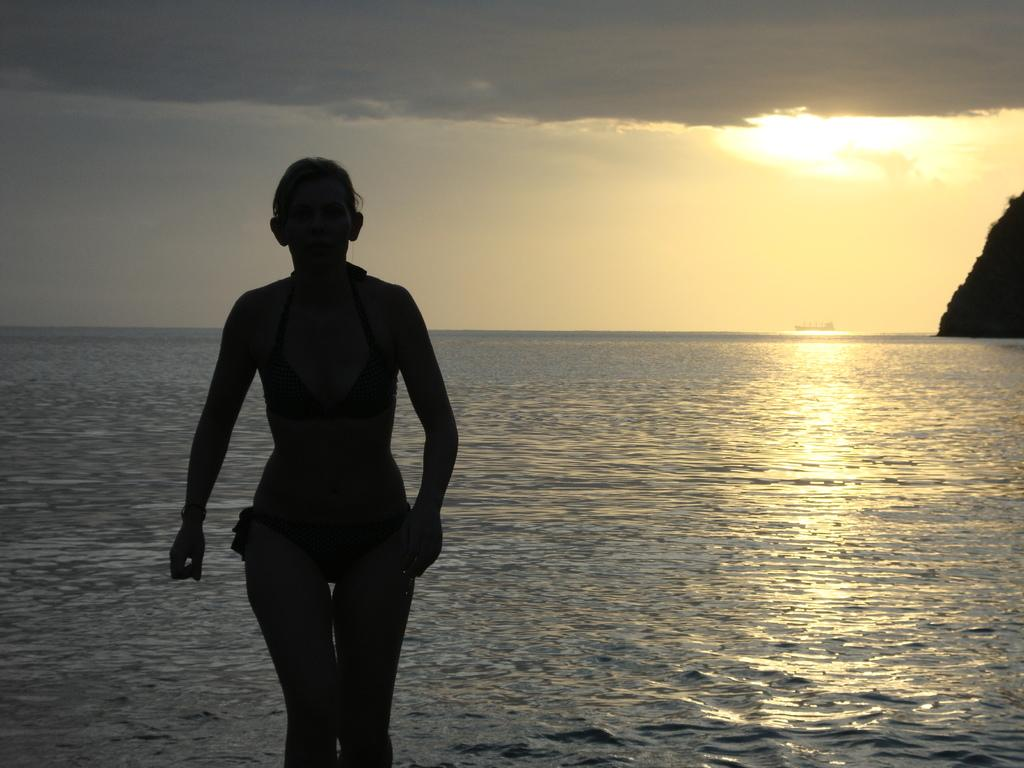What is the main subject of the image? There is a person standing in the image. Where is the person standing? The person is standing on a path. What can be seen in the background of the image? There is water and the sky visible in the image. What type of lock is being used to secure the person in the image? There is no lock present in the image, and the person is not secured. 